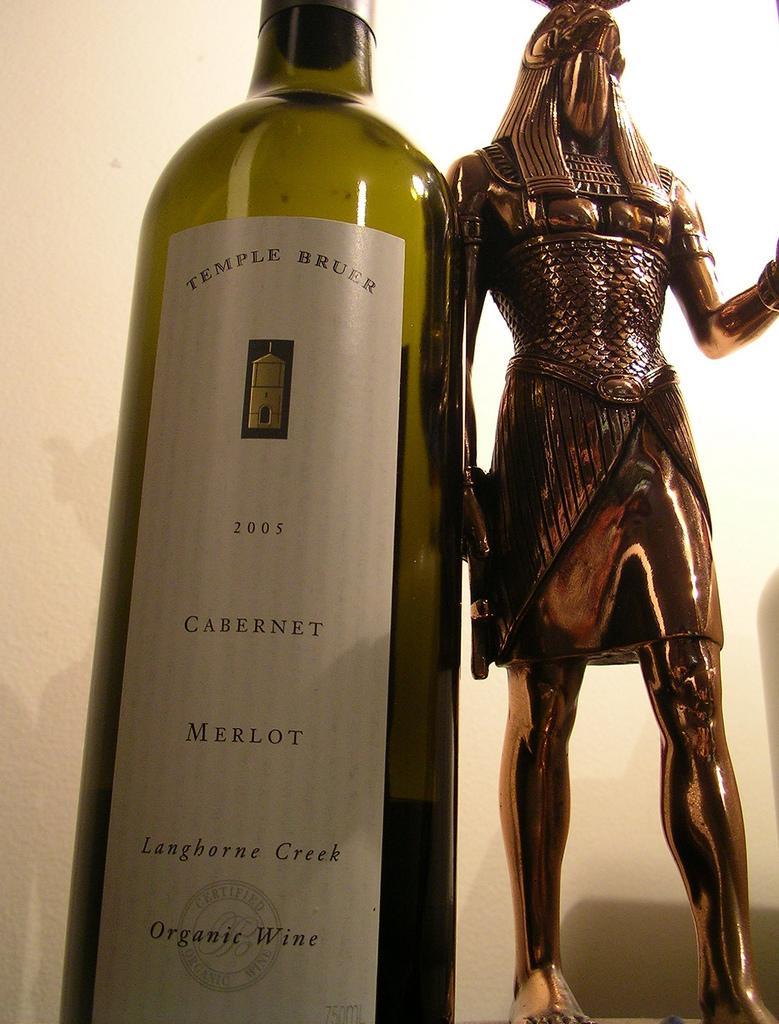Provide a one-sentence caption for the provided image. The bottle of wine is from the company Temple Bruer. 